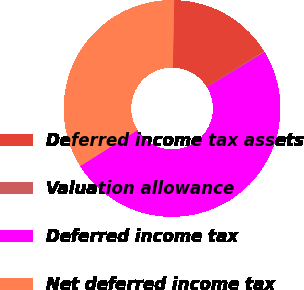Convert chart. <chart><loc_0><loc_0><loc_500><loc_500><pie_chart><fcel>Deferred income tax assets<fcel>Valuation allowance<fcel>Deferred income tax<fcel>Net deferred income tax<nl><fcel>15.77%<fcel>0.24%<fcel>49.76%<fcel>34.23%<nl></chart> 